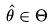<formula> <loc_0><loc_0><loc_500><loc_500>\hat { \theta } \in \Theta</formula> 